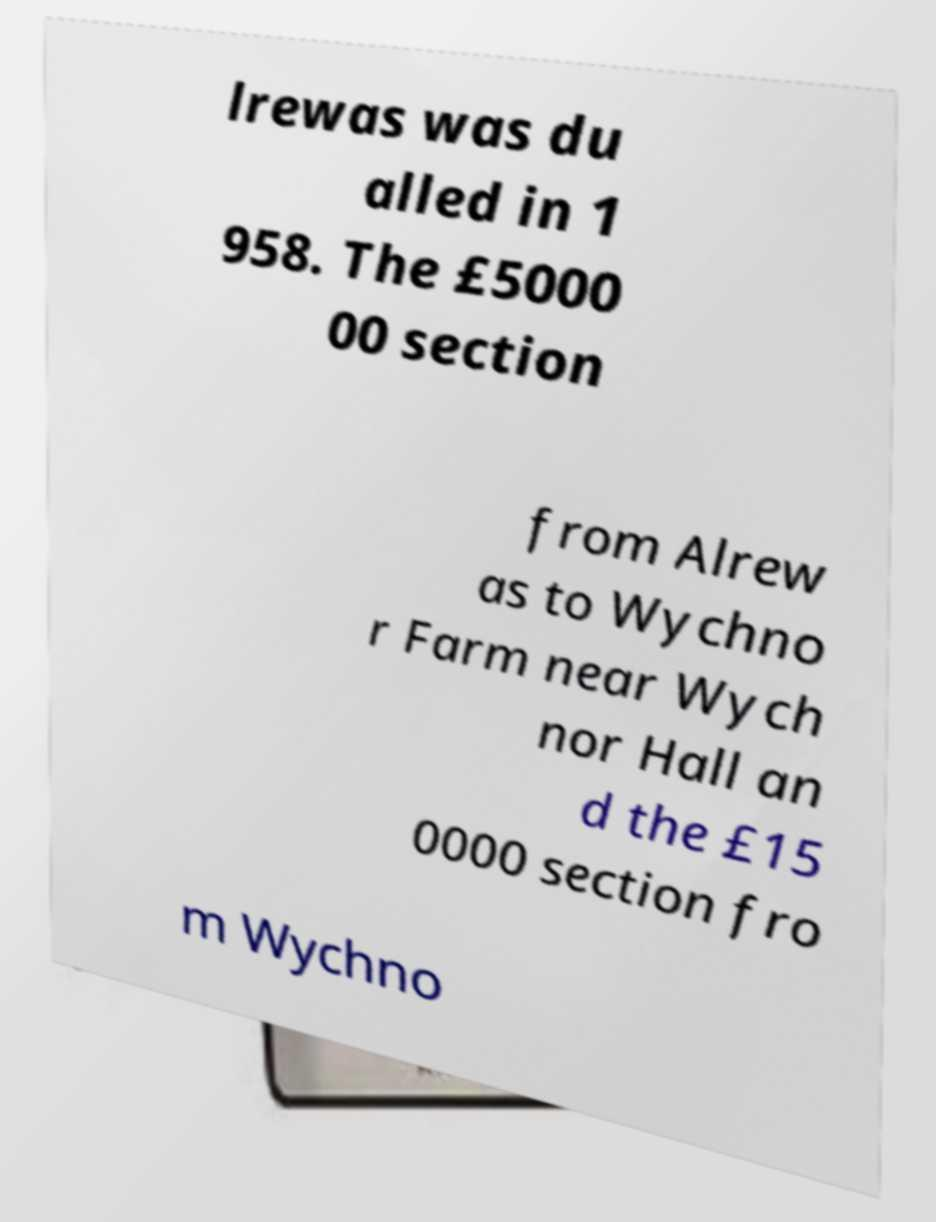Could you assist in decoding the text presented in this image and type it out clearly? lrewas was du alled in 1 958. The £5000 00 section from Alrew as to Wychno r Farm near Wych nor Hall an d the £15 0000 section fro m Wychno 